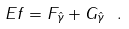<formula> <loc_0><loc_0><loc_500><loc_500>E f = F _ { \hat { \gamma } } + G _ { \hat { \gamma } } \ .</formula> 